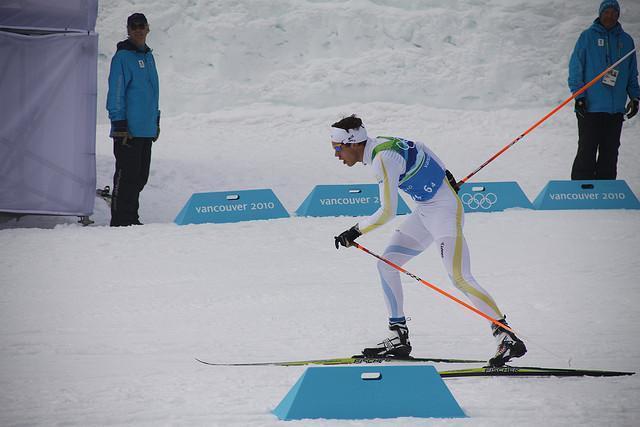How many people are in the picture?
Give a very brief answer. 3. 